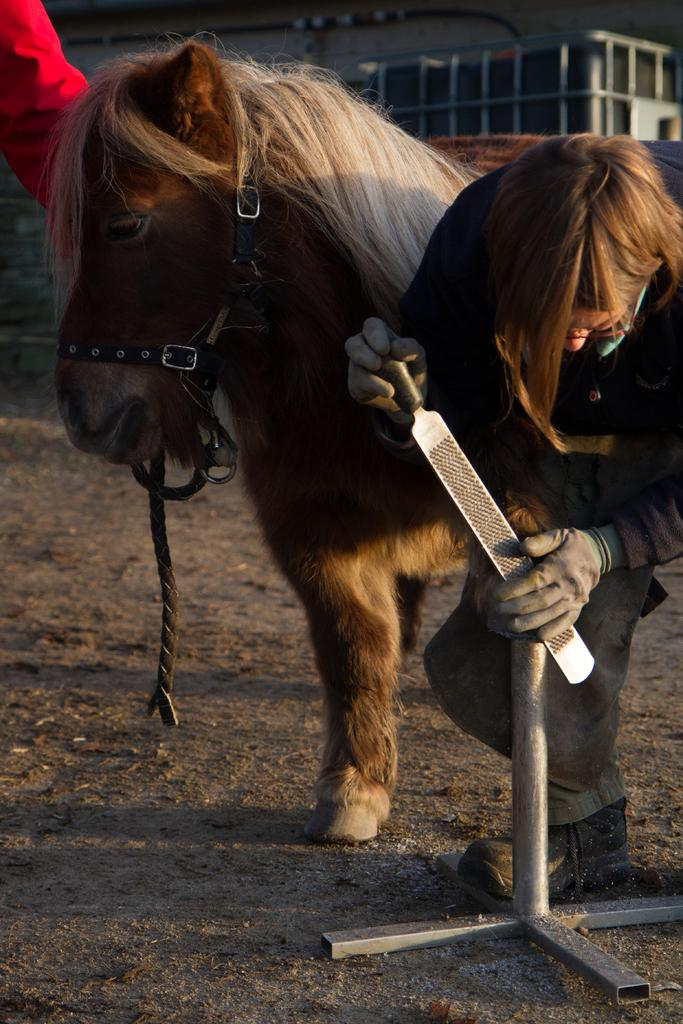What is the main subject of the image? There is a person in the image. What is the person holding in the image? The person is holding an object. What can be seen behind the person? There is a horse behind the person. Whose hand is visible in the image? The hand of another person is visible. What is visible in the background of the image? There is a building in the background of the image. Is the image taken during the night or day? The provided facts do not mention the time of day, so it cannot be determined whether the image is taken during the night or day. What type of zipper can be seen on the person's clothing in the image? There is no mention of a zipper on the person's clothing in the provided facts, so it cannot be determined whether a zipper is present or not. 